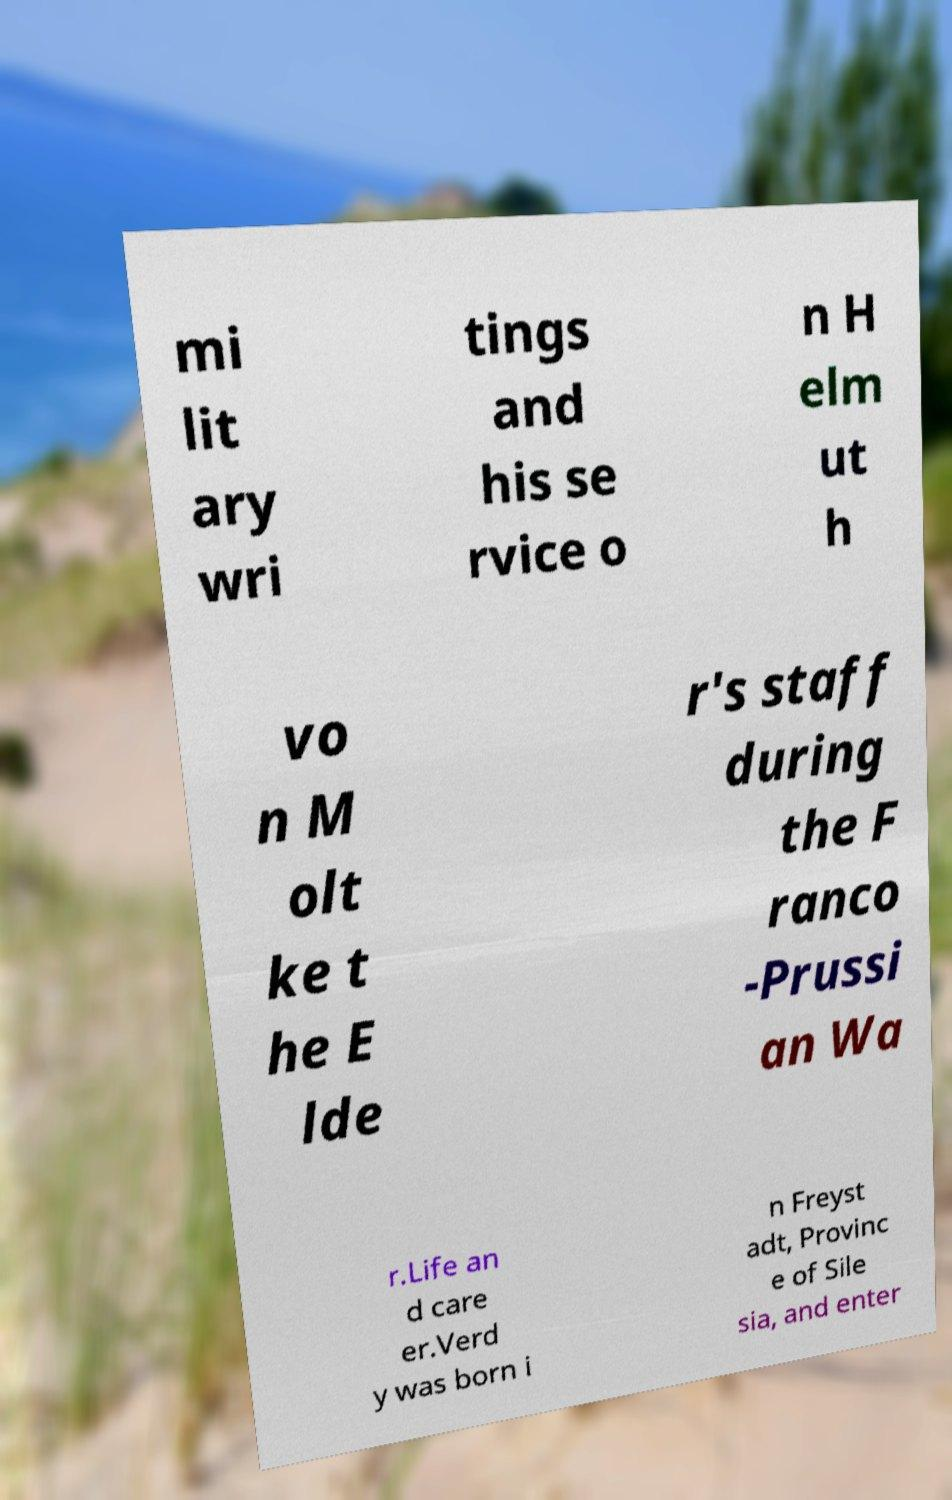For documentation purposes, I need the text within this image transcribed. Could you provide that? mi lit ary wri tings and his se rvice o n H elm ut h vo n M olt ke t he E lde r's staff during the F ranco -Prussi an Wa r.Life an d care er.Verd y was born i n Freyst adt, Provinc e of Sile sia, and enter 